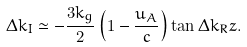<formula> <loc_0><loc_0><loc_500><loc_500>\Delta k _ { I } \simeq - \frac { 3 k _ { g } } { 2 } \left ( 1 - \frac { u _ { A } } { c } \right ) \tan \Delta k _ { R } z .</formula> 